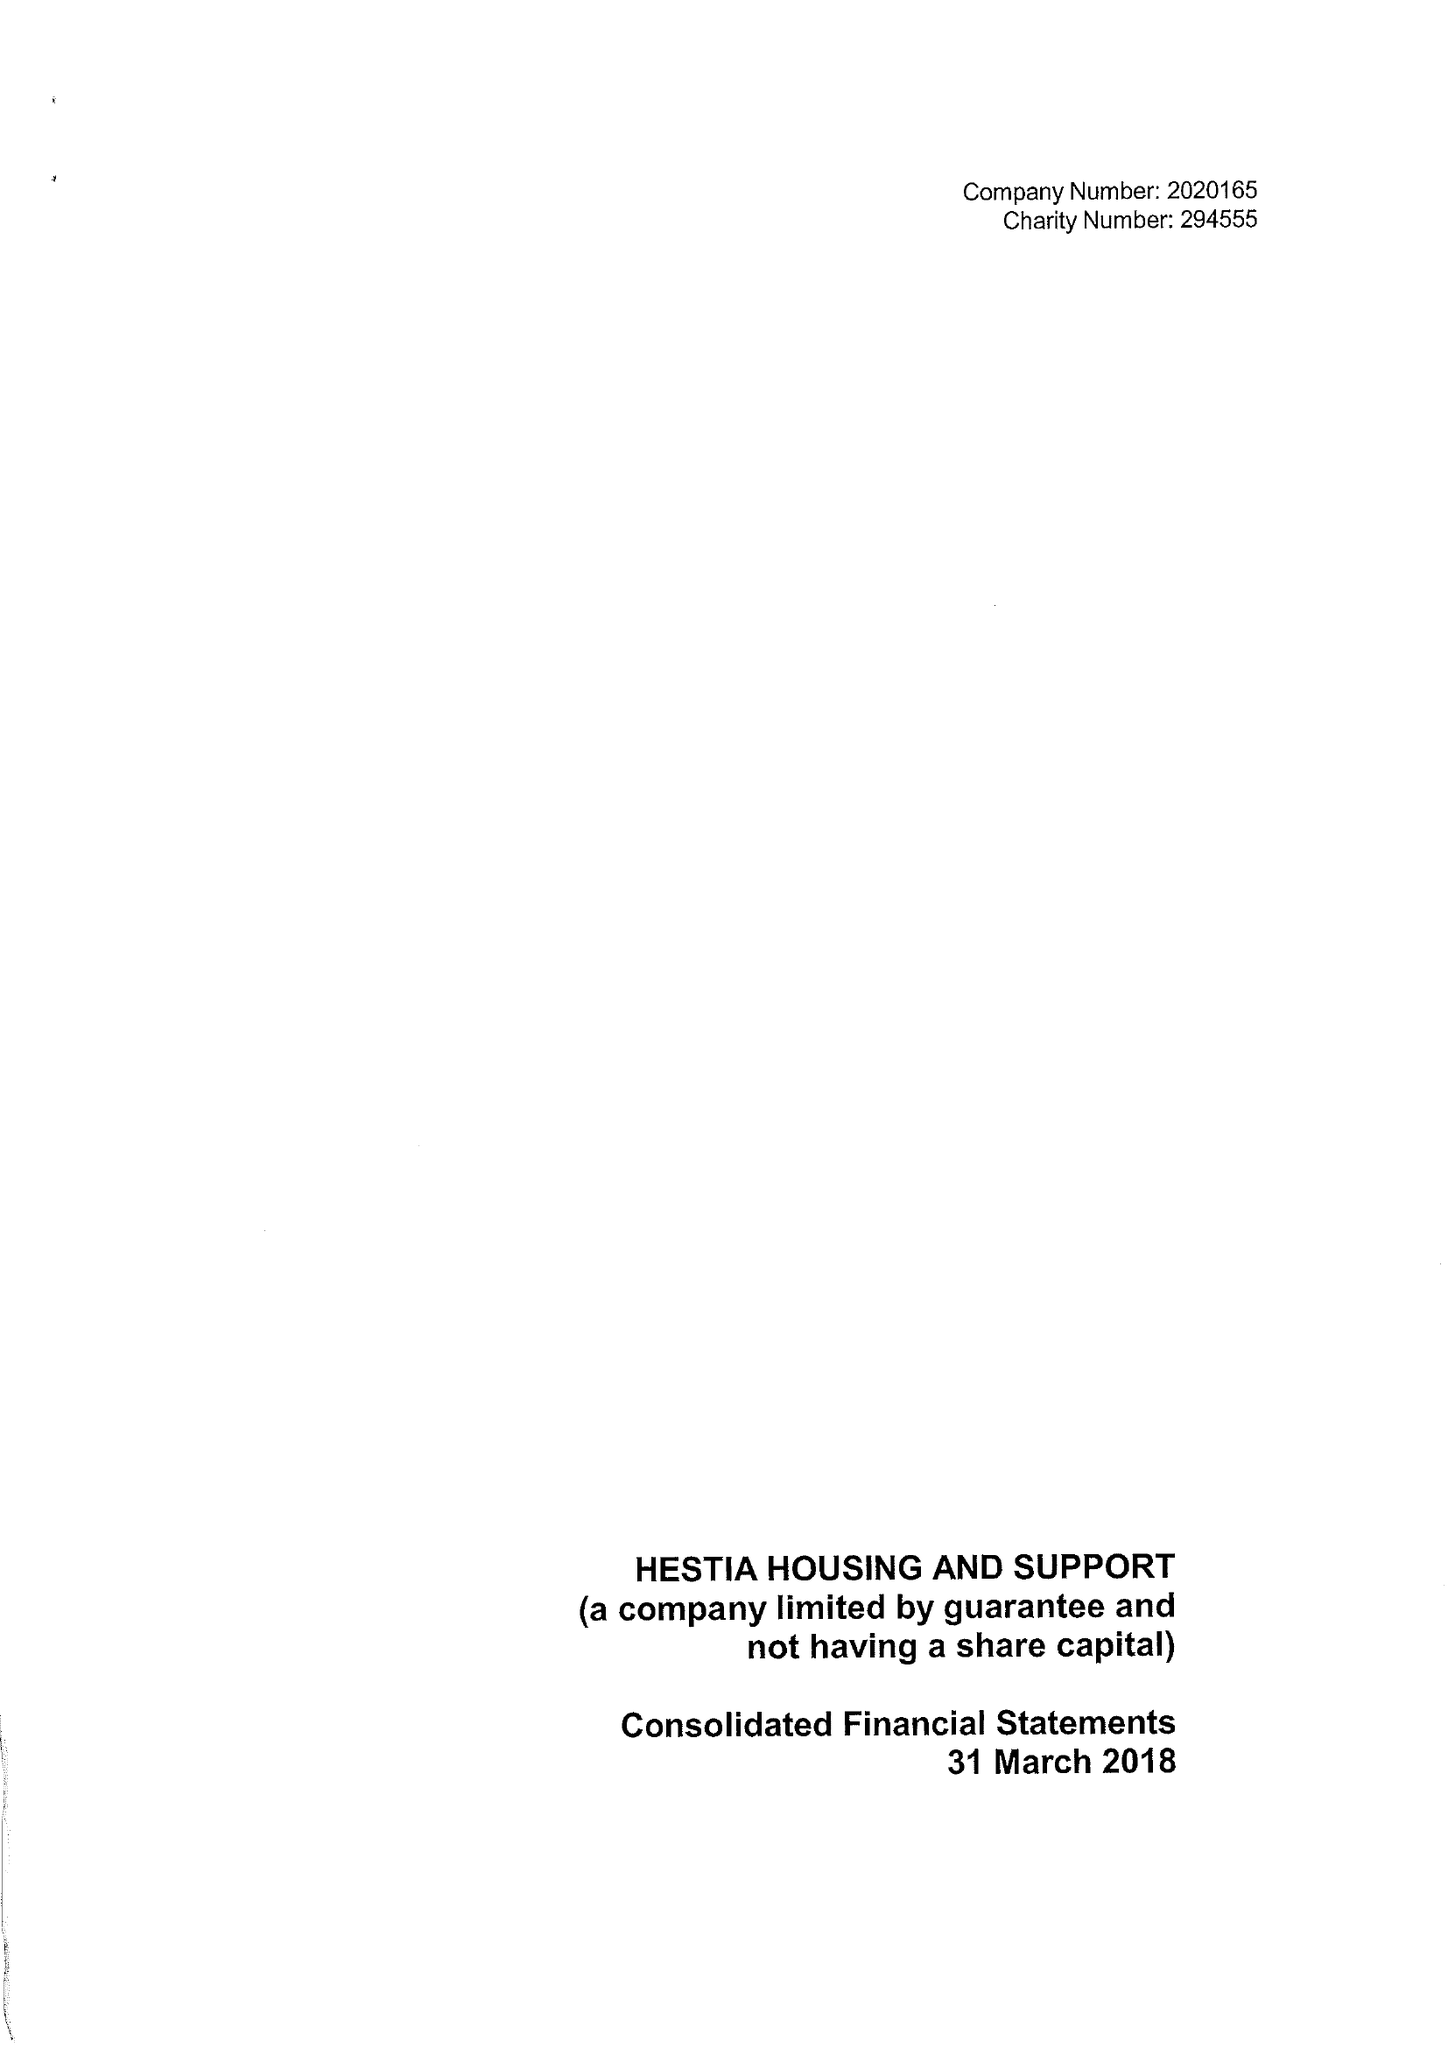What is the value for the address__street_line?
Answer the question using a single word or phrase. 134-138 BOROUGH HIGH STREET 